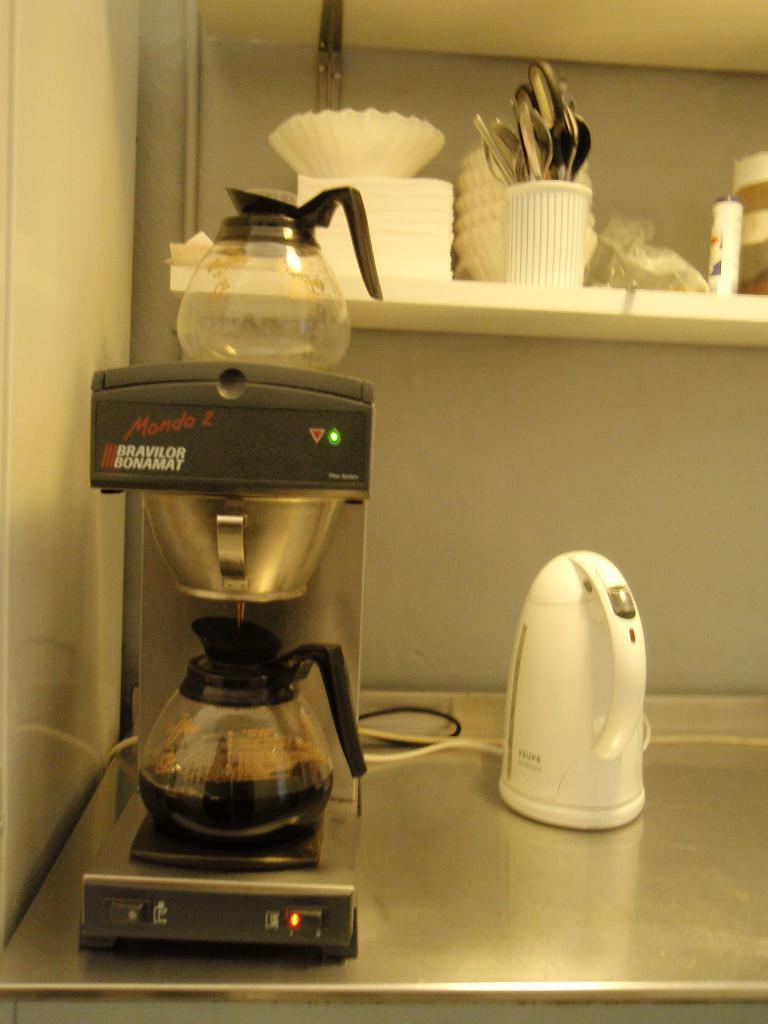Provide a one-sentence caption for the provided image. A Mondo 2 coffeemaker and warmer with coffee being poured in. 